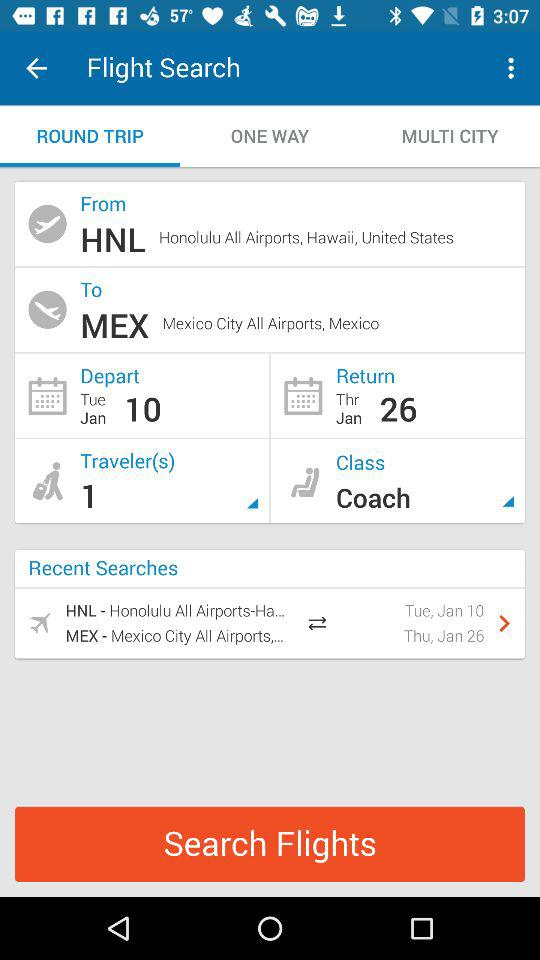How many people are traveling?
Answer the question using a single word or phrase. 1 